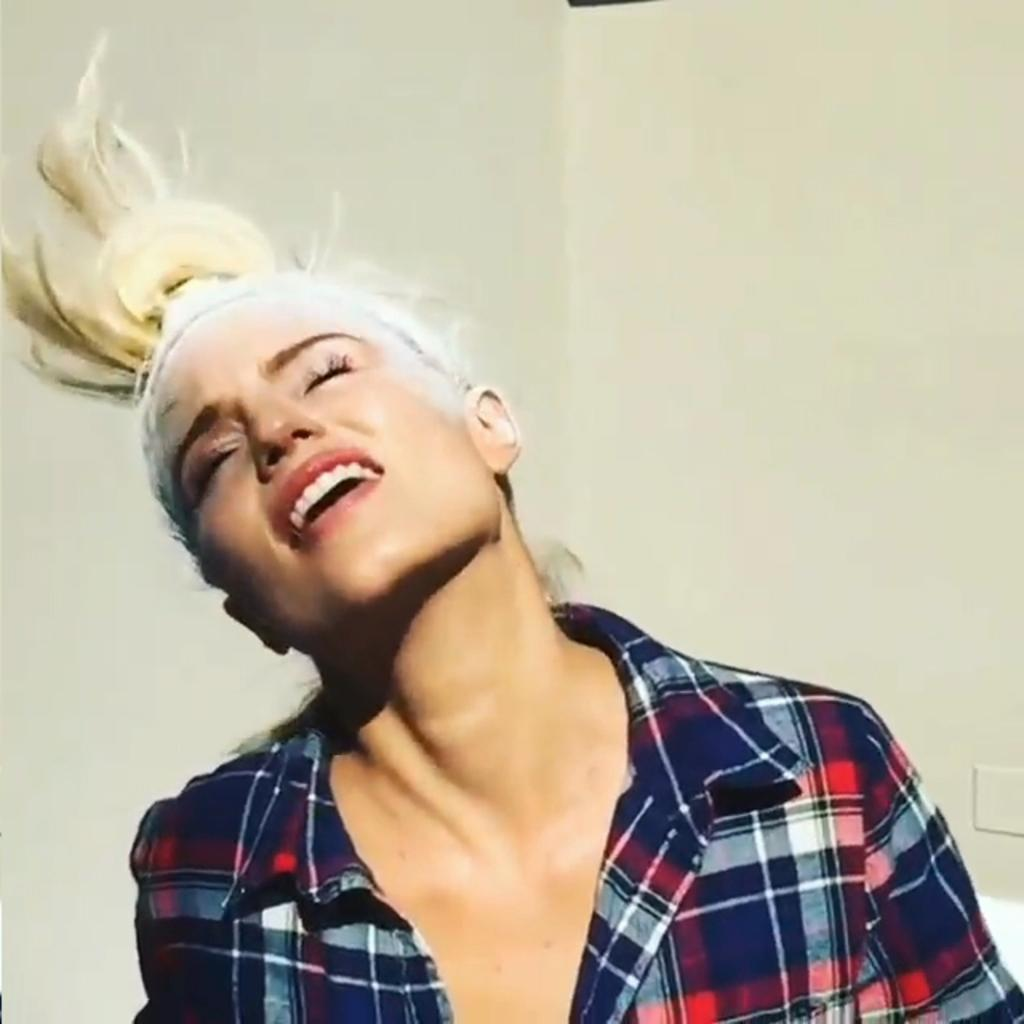Who is present in the image? There is a woman in the image. What is the woman's condition in the image? The woman is tied up in the image. What is the woman wearing in the image? The woman is wearing a check shirt in the image. What type of cactus can be seen in the background of the image? There is no cactus present in the image. What color is the sheet covering the woman in the image? The woman is not covered by a sheet in the image; she is tied up. 